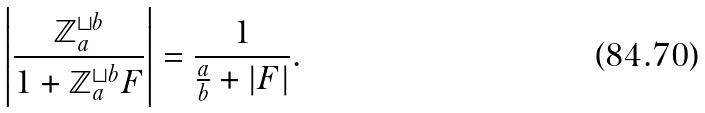Convert formula to latex. <formula><loc_0><loc_0><loc_500><loc_500>\left | \frac { \mathbb { Z } _ { a } ^ { \sqcup b } } { 1 + \mathbb { Z } _ { a } ^ { \sqcup b } F } \right | = \frac { 1 } { \frac { a } { b } + | F | } .</formula> 